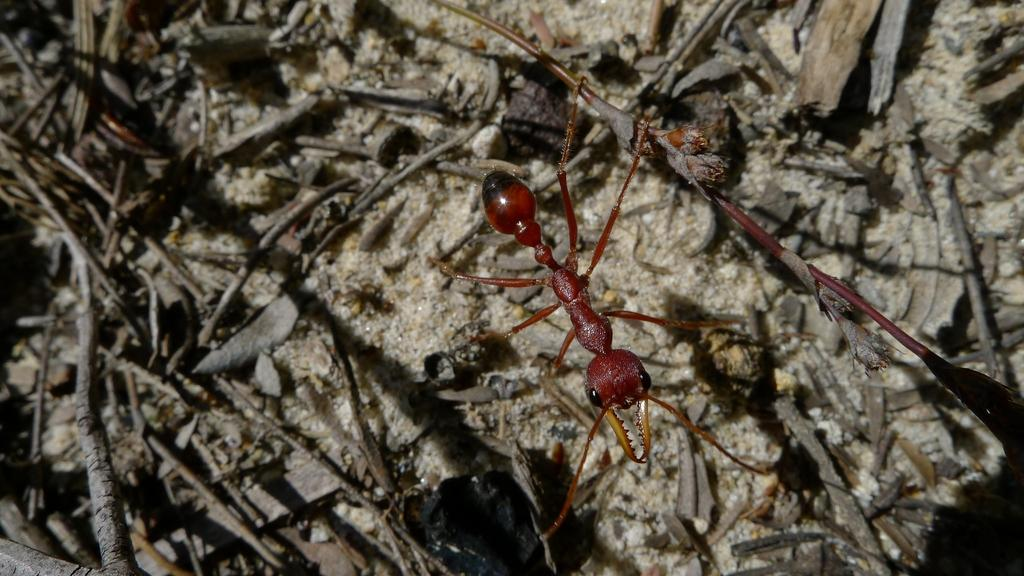What type of creature is in the image? There is an insect in the image. What colors can be seen on the insect? The insect has black, brown, and yellow coloring. What is the insect resting on in the image? The insect is on a cream-colored surface. What type of material can be seen in the image? There are wooden sticks in the image. What other objects are present in the image? There are other objects in the image, but their specific details are not mentioned in the provided facts. What type of hair is visible on the insect in the image? There is no hair visible on the insect in the image, as insects do not have hair. What type of arch can be seen in the image? There is no arch present in the image. 